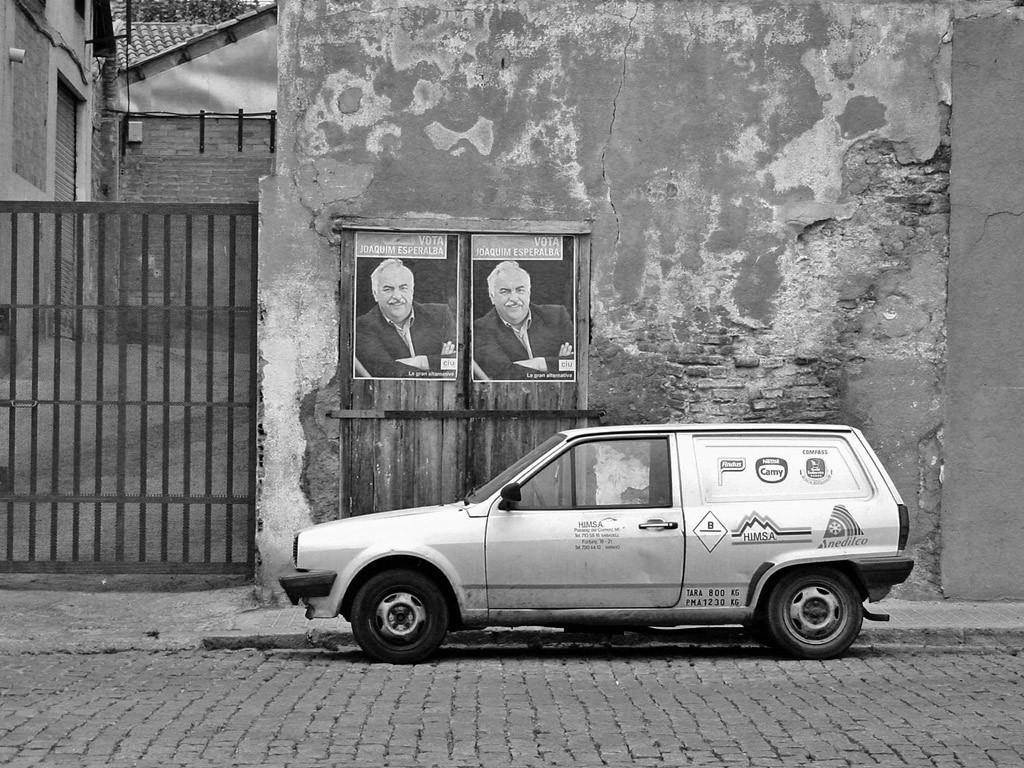What is the main subject of the image? The main subject of the image is a car. What can be seen on the wooden door in the image? There are posters on the wooden door. What type of structure is visible in the image? There is a wall, a gate, and a building visible in the image. What architectural feature is present in the image? There is a shutter in the image. What part of a building can be seen in the image? The roof top is visible in the image. How many lizards are crawling on the car in the image? There are no lizards visible in the image; the focus is on the car and the surrounding structures. 